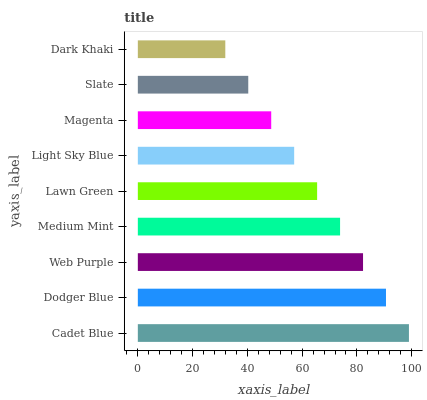Is Dark Khaki the minimum?
Answer yes or no. Yes. Is Cadet Blue the maximum?
Answer yes or no. Yes. Is Dodger Blue the minimum?
Answer yes or no. No. Is Dodger Blue the maximum?
Answer yes or no. No. Is Cadet Blue greater than Dodger Blue?
Answer yes or no. Yes. Is Dodger Blue less than Cadet Blue?
Answer yes or no. Yes. Is Dodger Blue greater than Cadet Blue?
Answer yes or no. No. Is Cadet Blue less than Dodger Blue?
Answer yes or no. No. Is Lawn Green the high median?
Answer yes or no. Yes. Is Lawn Green the low median?
Answer yes or no. Yes. Is Magenta the high median?
Answer yes or no. No. Is Dodger Blue the low median?
Answer yes or no. No. 